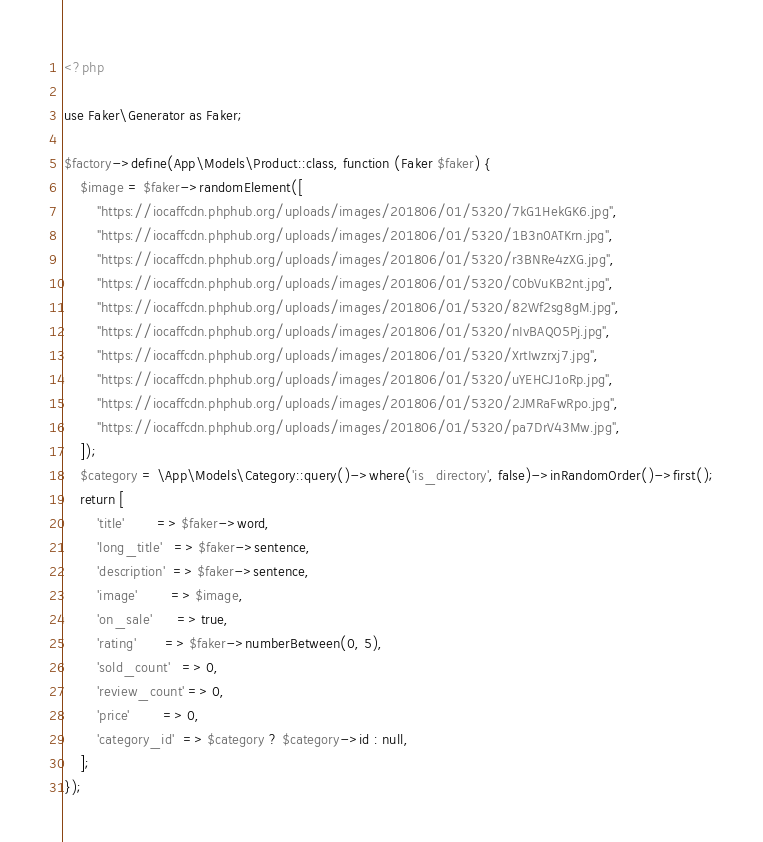Convert code to text. <code><loc_0><loc_0><loc_500><loc_500><_PHP_><?php

use Faker\Generator as Faker;

$factory->define(App\Models\Product::class, function (Faker $faker) {
    $image = $faker->randomElement([
        "https://iocaffcdn.phphub.org/uploads/images/201806/01/5320/7kG1HekGK6.jpg",
        "https://iocaffcdn.phphub.org/uploads/images/201806/01/5320/1B3n0ATKrn.jpg",
        "https://iocaffcdn.phphub.org/uploads/images/201806/01/5320/r3BNRe4zXG.jpg",
        "https://iocaffcdn.phphub.org/uploads/images/201806/01/5320/C0bVuKB2nt.jpg",
        "https://iocaffcdn.phphub.org/uploads/images/201806/01/5320/82Wf2sg8gM.jpg",
        "https://iocaffcdn.phphub.org/uploads/images/201806/01/5320/nIvBAQO5Pj.jpg",
        "https://iocaffcdn.phphub.org/uploads/images/201806/01/5320/XrtIwzrxj7.jpg",
        "https://iocaffcdn.phphub.org/uploads/images/201806/01/5320/uYEHCJ1oRp.jpg",
        "https://iocaffcdn.phphub.org/uploads/images/201806/01/5320/2JMRaFwRpo.jpg",
        "https://iocaffcdn.phphub.org/uploads/images/201806/01/5320/pa7DrV43Mw.jpg",
    ]);
    $category = \App\Models\Category::query()->where('is_directory', false)->inRandomOrder()->first();
    return [
        'title'        => $faker->word,
        'long_title'   => $faker->sentence,
        'description'  => $faker->sentence,
        'image'        => $image,
        'on_sale'      => true,
        'rating'       => $faker->numberBetween(0, 5),
        'sold_count'   => 0,
        'review_count' => 0,
        'price'        => 0,
        'category_id'  => $category ? $category->id : null,
    ];
});
</code> 